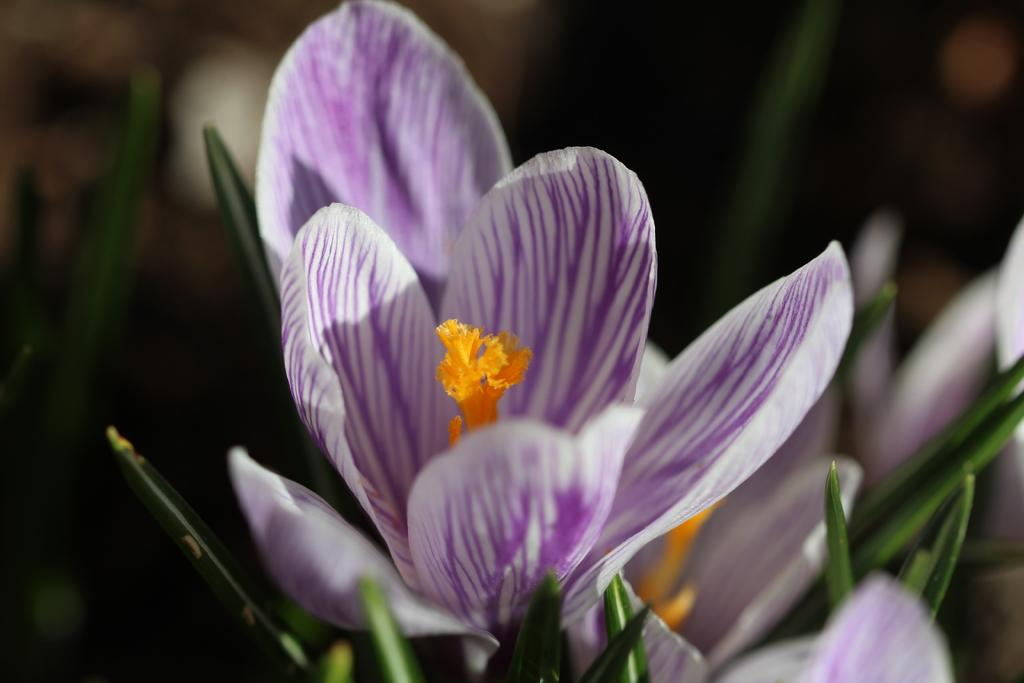What type of plants can be seen in the image? There are flowers and leaves in the image. Can you describe the background of the image? The background of the image is blurred. What type of brake system is visible on the truck in the image? There is no truck present in the image, so there is no brake system to observe. 